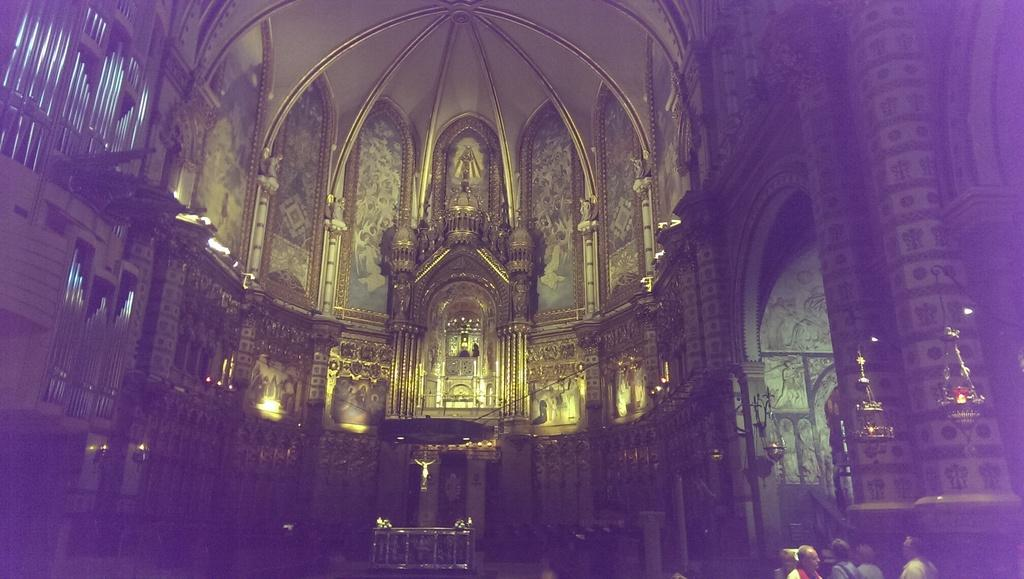Where was the image taken? The image was taken inside a church. What architectural feature can be seen in the image? There is a dome ceiling and an arch in the image. What type of decorations are present in the image? There are sculptures in the image. What object is used for holding candles? There is a candle holder in the image. Are there any people visible in the image? Yes, there are people on the right bottom side of the image. What type of hose is being used to water the plants in the image? There are no plants or hoses present in the image; it is taken inside a church. How does the rail contribute to the overall design of the church in the image? There is no rail mentioned or visible in the image. 